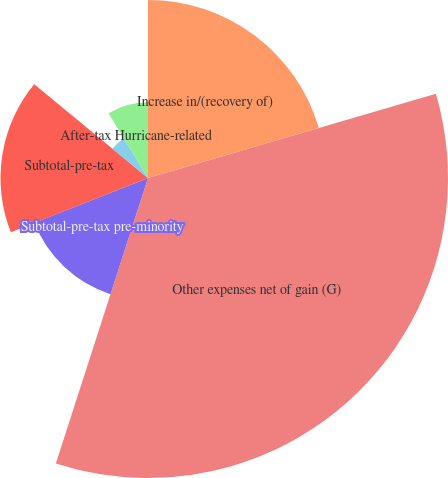Convert chart to OTSL. <chart><loc_0><loc_0><loc_500><loc_500><pie_chart><fcel>Increase in/(recovery of)<fcel>Other expenses net of gain (G)<fcel>Subtotal-pre-tax pre-minority<fcel>Subtotal-pre-tax<fcel>Income tax benefit<fcel>After-tax Hurricane-related<nl><fcel>20.47%<fcel>34.5%<fcel>14.04%<fcel>16.96%<fcel>5.31%<fcel>8.72%<nl></chart> 